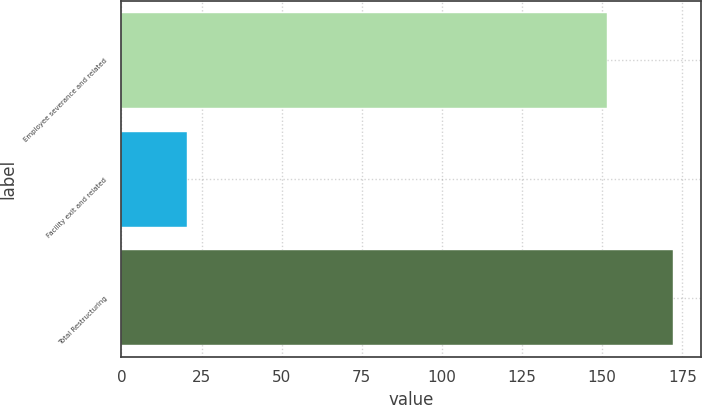<chart> <loc_0><loc_0><loc_500><loc_500><bar_chart><fcel>Employee severance and related<fcel>Facility exit and related<fcel>Total Restructuring<nl><fcel>151.6<fcel>20.6<fcel>172.2<nl></chart> 